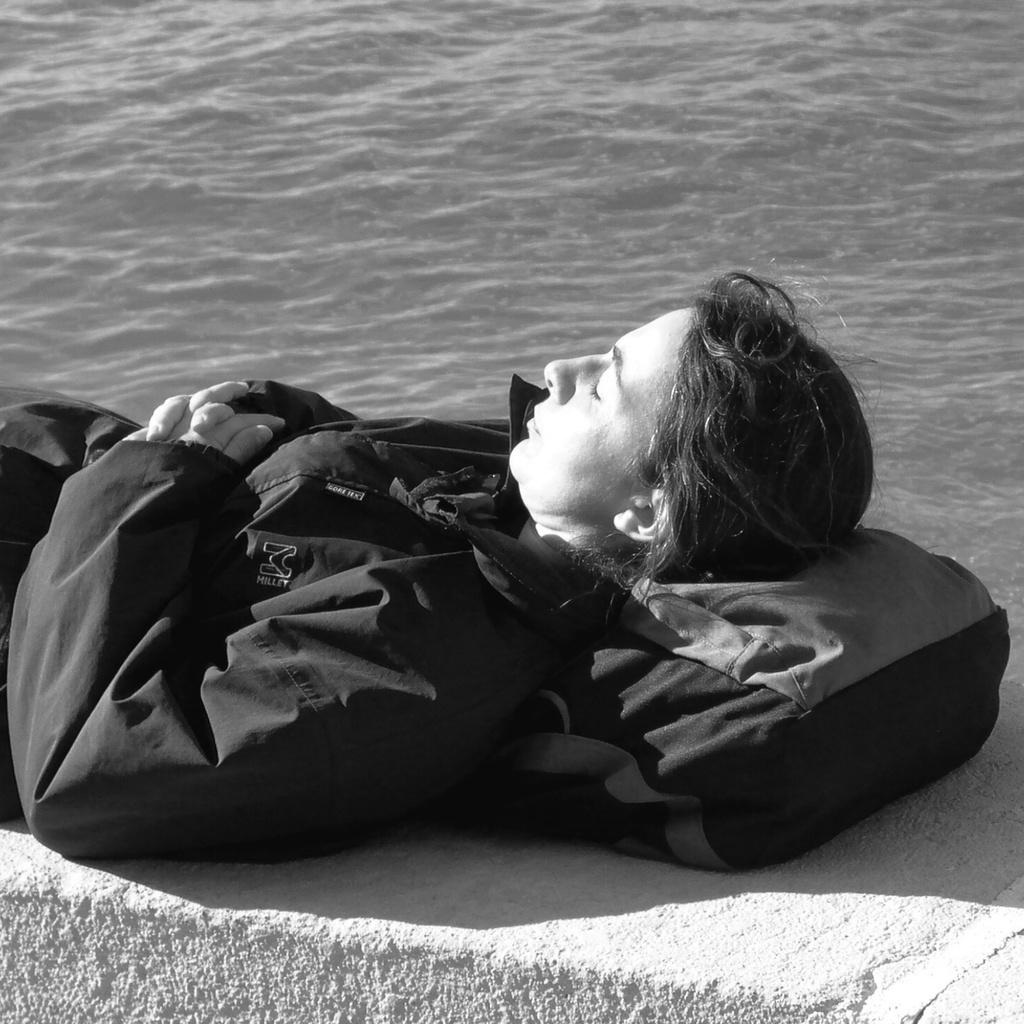What is the color scheme of the image? The image is black and white. What is the person in the image doing? The person is sleeping in the image. What is the person using as a makeshift bed? The person is using a small wall as a makeshift bed. What is the person using as a pillow? The person has a bag under their head. What can be seen in the background of the image? There is a river in the background of the image. How many ladybugs can be seen crawling on the person's bag in the image? There are no ladybugs visible in the image; the person has a bag under their head, but no insects are present. What type of kitten is sitting next to the river in the background of the image? There is no kitten present in the image; the background only features a river. 